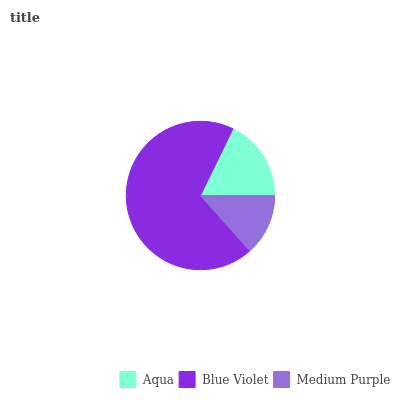Is Medium Purple the minimum?
Answer yes or no. Yes. Is Blue Violet the maximum?
Answer yes or no. Yes. Is Blue Violet the minimum?
Answer yes or no. No. Is Medium Purple the maximum?
Answer yes or no. No. Is Blue Violet greater than Medium Purple?
Answer yes or no. Yes. Is Medium Purple less than Blue Violet?
Answer yes or no. Yes. Is Medium Purple greater than Blue Violet?
Answer yes or no. No. Is Blue Violet less than Medium Purple?
Answer yes or no. No. Is Aqua the high median?
Answer yes or no. Yes. Is Aqua the low median?
Answer yes or no. Yes. Is Medium Purple the high median?
Answer yes or no. No. Is Medium Purple the low median?
Answer yes or no. No. 